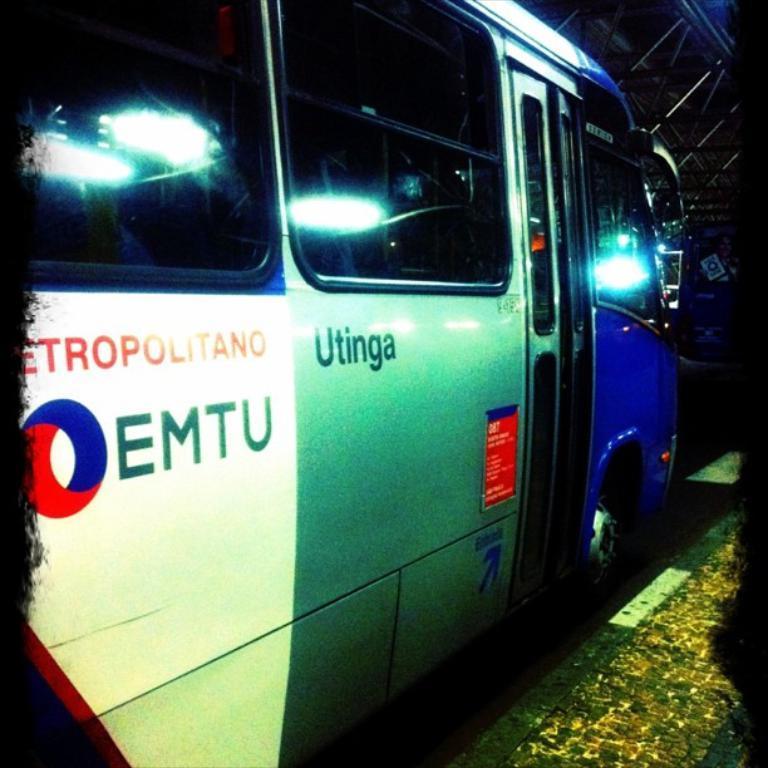Could you give a brief overview of what you see in this image? In this image I can see on the left side it is a bus with white, grey and blue color. There are glasses to it, at the bottom it looks like a footpath. 